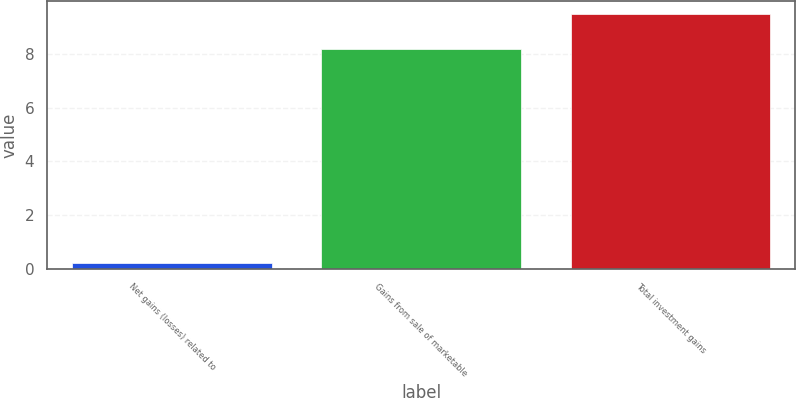Convert chart to OTSL. <chart><loc_0><loc_0><loc_500><loc_500><bar_chart><fcel>Net gains (losses) related to<fcel>Gains from sale of marketable<fcel>Total investment gains<nl><fcel>0.2<fcel>8.2<fcel>9.5<nl></chart> 